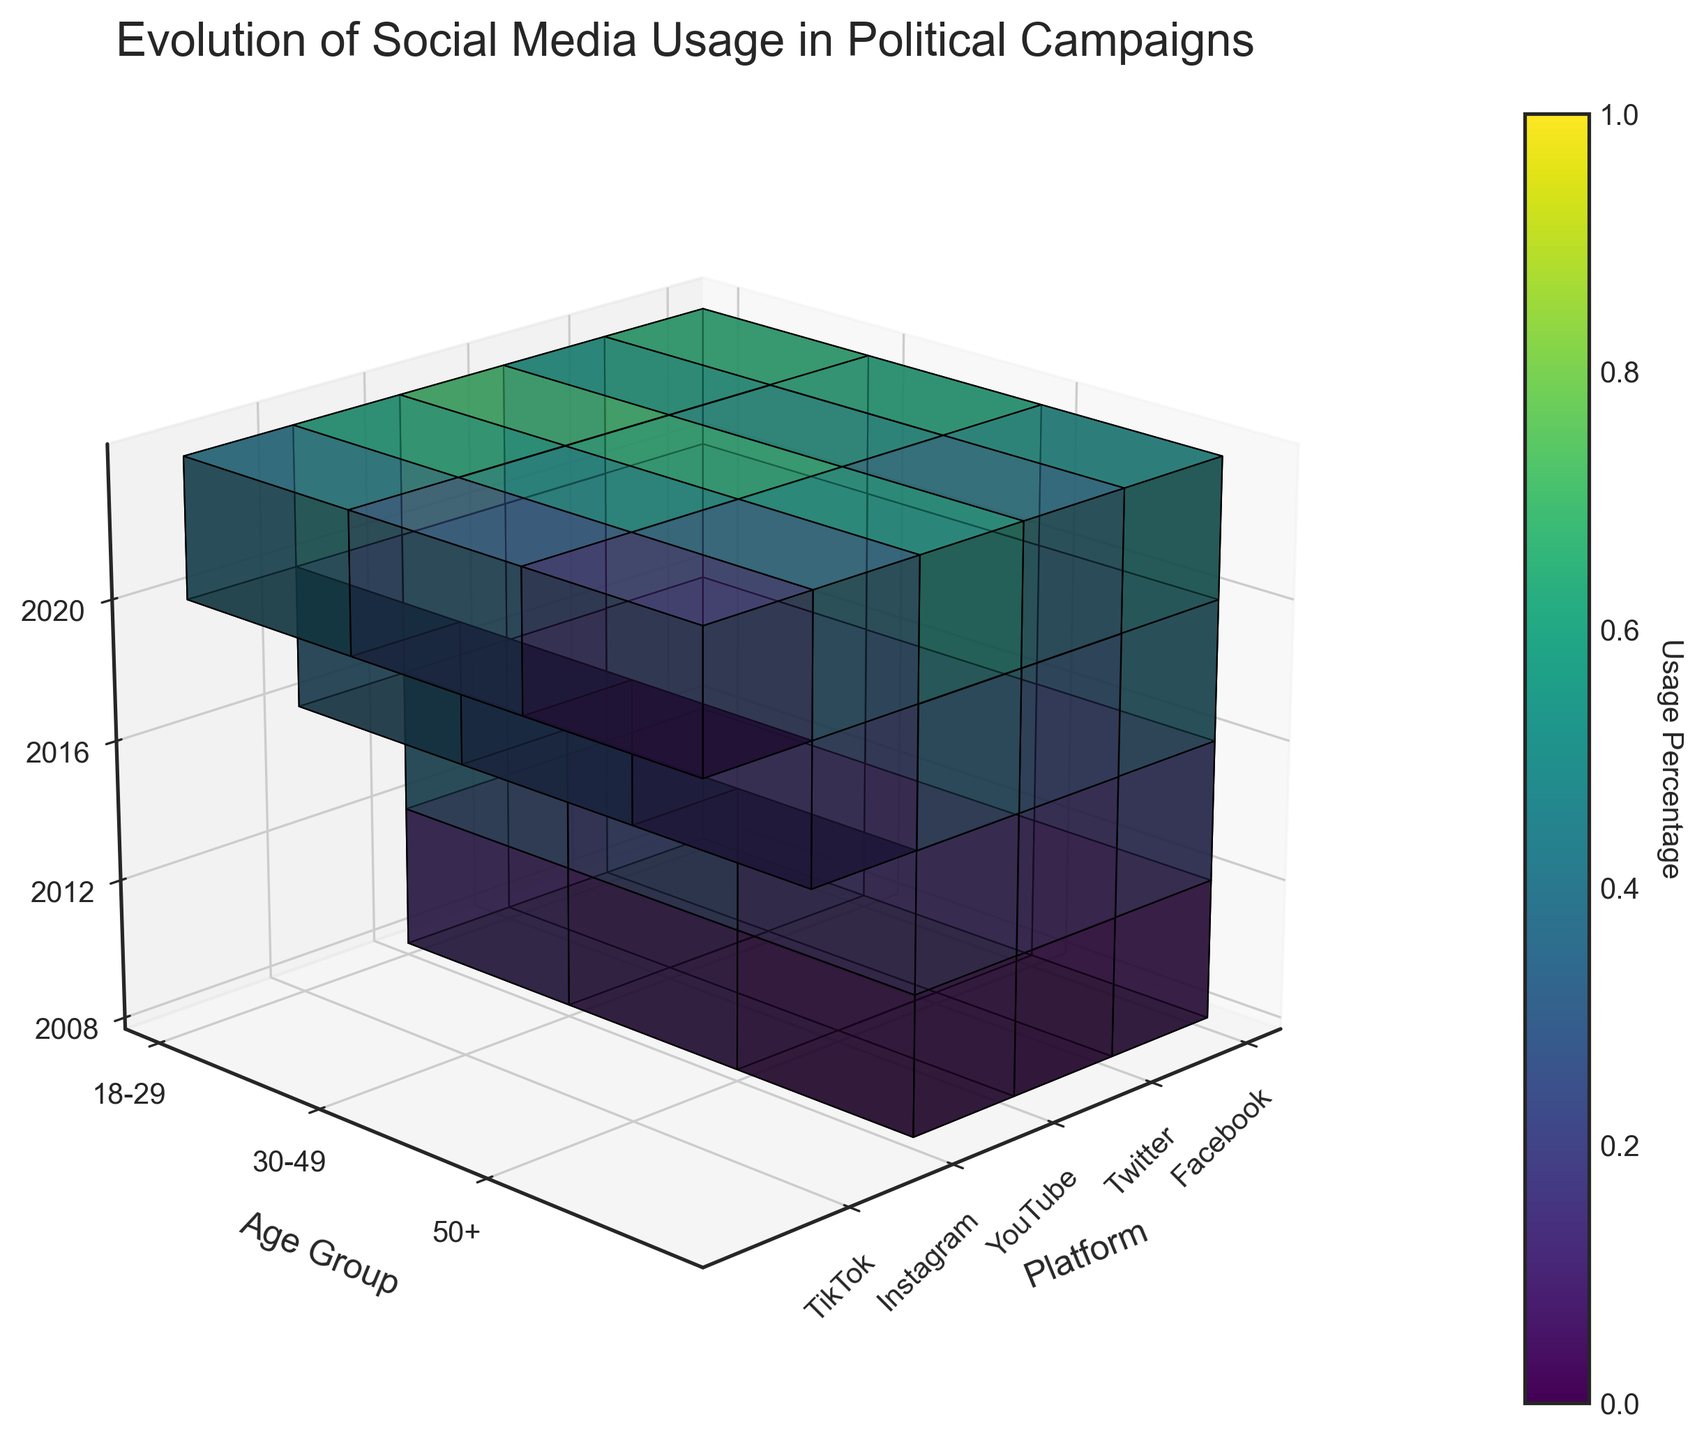What is the title of the figure? The title is located at the top of the figure and it is clearly labeled. The title is "Evolution of Social Media Usage in Political Campaigns".
Answer: Evolution of Social Media Usage in Political Campaigns Which platform had the highest usage percentage among the 18-29 age group in 2020? In 2020 for the 18-29 age group, by comparing the heights of the voxels and their colors, YouTube shows the highest usage percentage.
Answer: YouTube How did the usage of Facebook among the 30-49 age group change from 2008 to 2020? First, locate the voxels corresponding to Facebook and the 30-49 age group across the years. Notice the change in height and color intensity from 2008 (10%) to 2020 (62%).
Answer: Increased What is the difference in YouTube usage percentage between the 18-29 and 50+ age groups in 2016? For 2016, identify YouTube's corresponding voxels for the 18-29 age group (55%) and the 50+ age group (35%). Subtract the smaller value from the larger one: 55% - 35% = 20%.
Answer: 20% Which age group showed the least usage percentage for TikTok in 2020? In 2020, among all age groups for TikTok, the voxel with the smallest height and the least color intensity corresponds to the 50+ age group (10%).
Answer: 50+ How did the overall social media usage trend for the 50+ age group evolve from 2008 to 2020? By examining the voxels corresponding to different platforms for 50+ age group across the years, observe that the heights and color intensities increase from 2008 to 2020.
Answer: Increased Compare the Instagram usage percentages between the 18-29 and 30-49 age groups in 2020. Which group has higher usage? In 2020, compare the height and color intensity of Instagram voxels for the 18-29 (60%) and the 30-49 (50%) age groups. The 18-29 age group has a higher usage.
Answer: 18-29 Which platform exhibited an introduction in the dataset in 2016? By examining the years, notice that Instagram is present starting from 2016, indicating its introduction in the figure in that year.
Answer: Instagram 